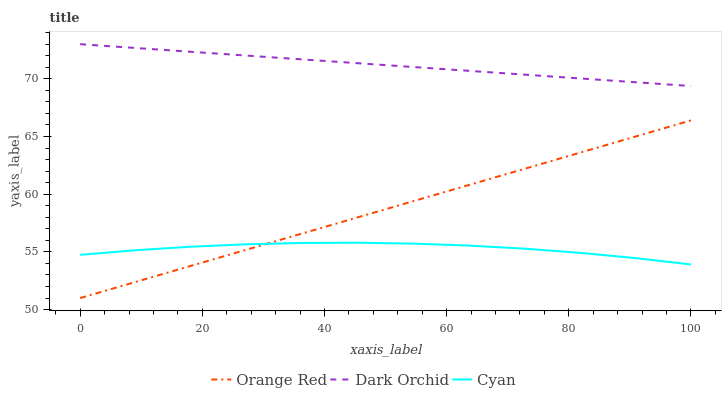Does Cyan have the minimum area under the curve?
Answer yes or no. Yes. Does Dark Orchid have the maximum area under the curve?
Answer yes or no. Yes. Does Orange Red have the minimum area under the curve?
Answer yes or no. No. Does Orange Red have the maximum area under the curve?
Answer yes or no. No. Is Dark Orchid the smoothest?
Answer yes or no. Yes. Is Cyan the roughest?
Answer yes or no. Yes. Is Orange Red the smoothest?
Answer yes or no. No. Is Orange Red the roughest?
Answer yes or no. No. Does Orange Red have the lowest value?
Answer yes or no. Yes. Does Dark Orchid have the lowest value?
Answer yes or no. No. Does Dark Orchid have the highest value?
Answer yes or no. Yes. Does Orange Red have the highest value?
Answer yes or no. No. Is Orange Red less than Dark Orchid?
Answer yes or no. Yes. Is Dark Orchid greater than Orange Red?
Answer yes or no. Yes. Does Cyan intersect Orange Red?
Answer yes or no. Yes. Is Cyan less than Orange Red?
Answer yes or no. No. Is Cyan greater than Orange Red?
Answer yes or no. No. Does Orange Red intersect Dark Orchid?
Answer yes or no. No. 